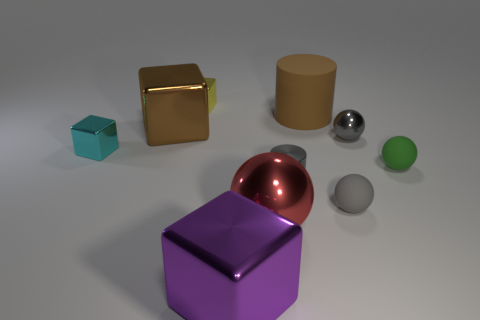Subtract all cubes. How many objects are left? 6 Subtract all yellow cubes. How many cubes are left? 3 Subtract 2 cubes. How many cubes are left? 2 Subtract all cyan cylinders. Subtract all purple balls. How many cylinders are left? 2 Subtract all gray balls. How many gray cubes are left? 0 Subtract all tiny gray cylinders. Subtract all small yellow cubes. How many objects are left? 8 Add 4 tiny yellow shiny cubes. How many tiny yellow shiny cubes are left? 5 Add 1 tiny purple objects. How many tiny purple objects exist? 1 Subtract all cyan cubes. How many cubes are left? 3 Subtract 1 cyan blocks. How many objects are left? 9 